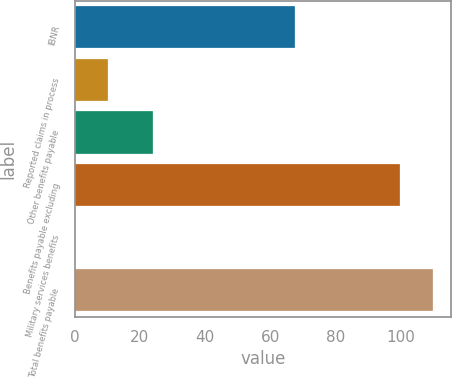<chart> <loc_0><loc_0><loc_500><loc_500><bar_chart><fcel>IBNR<fcel>Reported claims in process<fcel>Other benefits payable<fcel>Benefits payable excluding<fcel>Military services benefits<fcel>Total benefits payable<nl><fcel>67.5<fcel>10.09<fcel>24.1<fcel>99.9<fcel>0.1<fcel>109.89<nl></chart> 